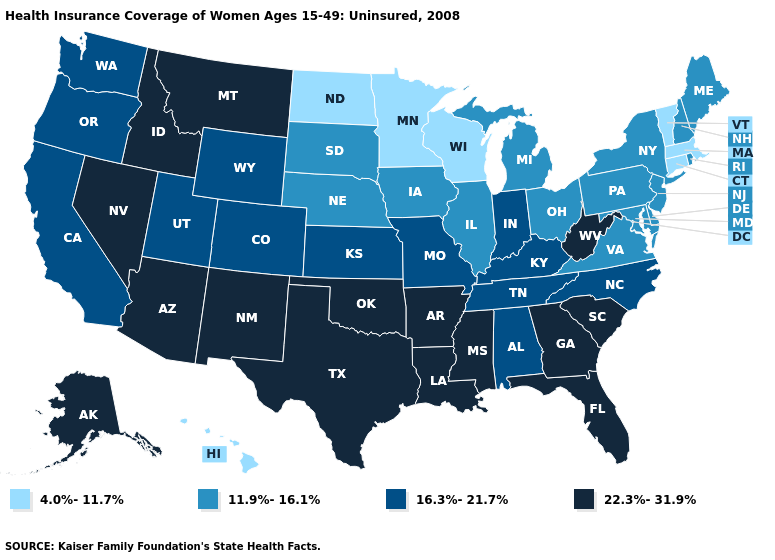What is the value of Alabama?
Be succinct. 16.3%-21.7%. What is the value of Missouri?
Short answer required. 16.3%-21.7%. Does Missouri have the highest value in the MidWest?
Answer briefly. Yes. What is the value of Maryland?
Concise answer only. 11.9%-16.1%. Name the states that have a value in the range 4.0%-11.7%?
Short answer required. Connecticut, Hawaii, Massachusetts, Minnesota, North Dakota, Vermont, Wisconsin. What is the highest value in the MidWest ?
Keep it brief. 16.3%-21.7%. What is the value of Maine?
Concise answer only. 11.9%-16.1%. Name the states that have a value in the range 4.0%-11.7%?
Give a very brief answer. Connecticut, Hawaii, Massachusetts, Minnesota, North Dakota, Vermont, Wisconsin. Does the first symbol in the legend represent the smallest category?
Concise answer only. Yes. Does Maryland have the same value as Nevada?
Short answer required. No. Which states have the lowest value in the USA?
Keep it brief. Connecticut, Hawaii, Massachusetts, Minnesota, North Dakota, Vermont, Wisconsin. Which states have the lowest value in the USA?
Give a very brief answer. Connecticut, Hawaii, Massachusetts, Minnesota, North Dakota, Vermont, Wisconsin. Name the states that have a value in the range 16.3%-21.7%?
Be succinct. Alabama, California, Colorado, Indiana, Kansas, Kentucky, Missouri, North Carolina, Oregon, Tennessee, Utah, Washington, Wyoming. Among the states that border North Dakota , which have the highest value?
Write a very short answer. Montana. 